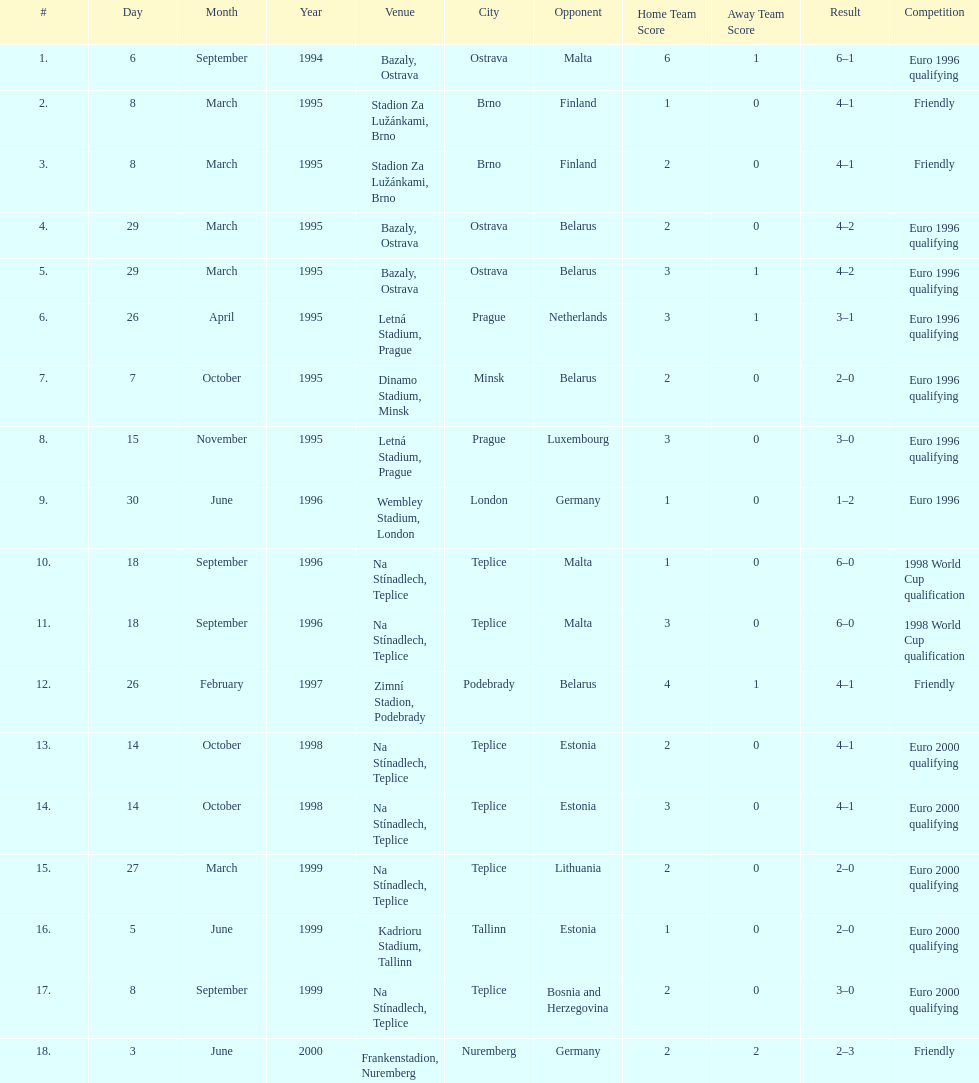What was the number of times czech republic played against germany? 2. 